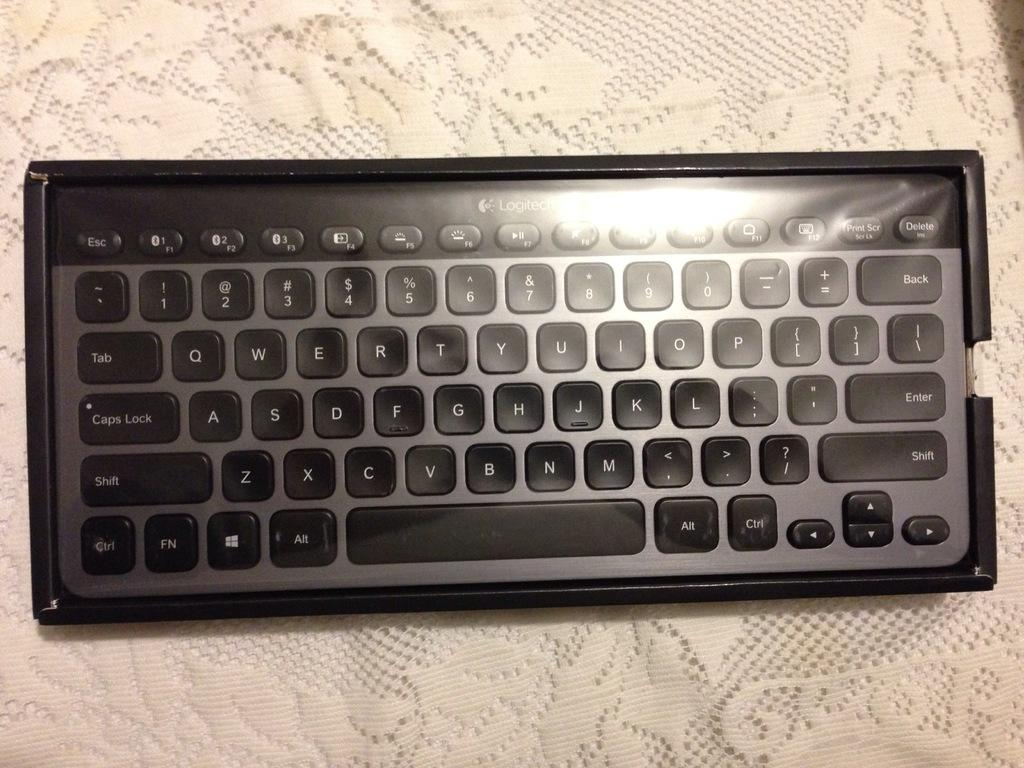<image>
Give a short and clear explanation of the subsequent image. black and silver logitech keyboard on a knit tablecloth 